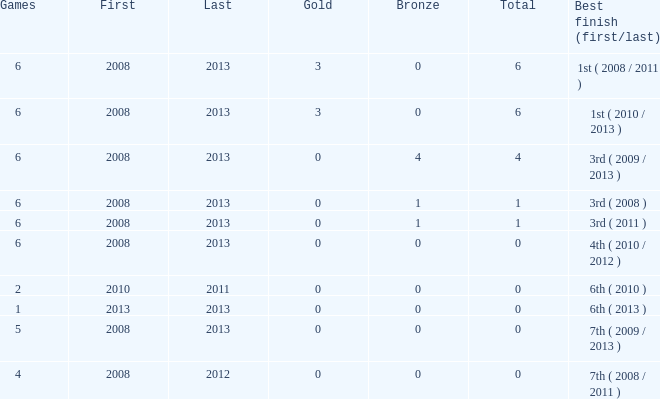What is the newest starting year with 0 cumulative medals and in excess of 0 golds? 2008.0. 